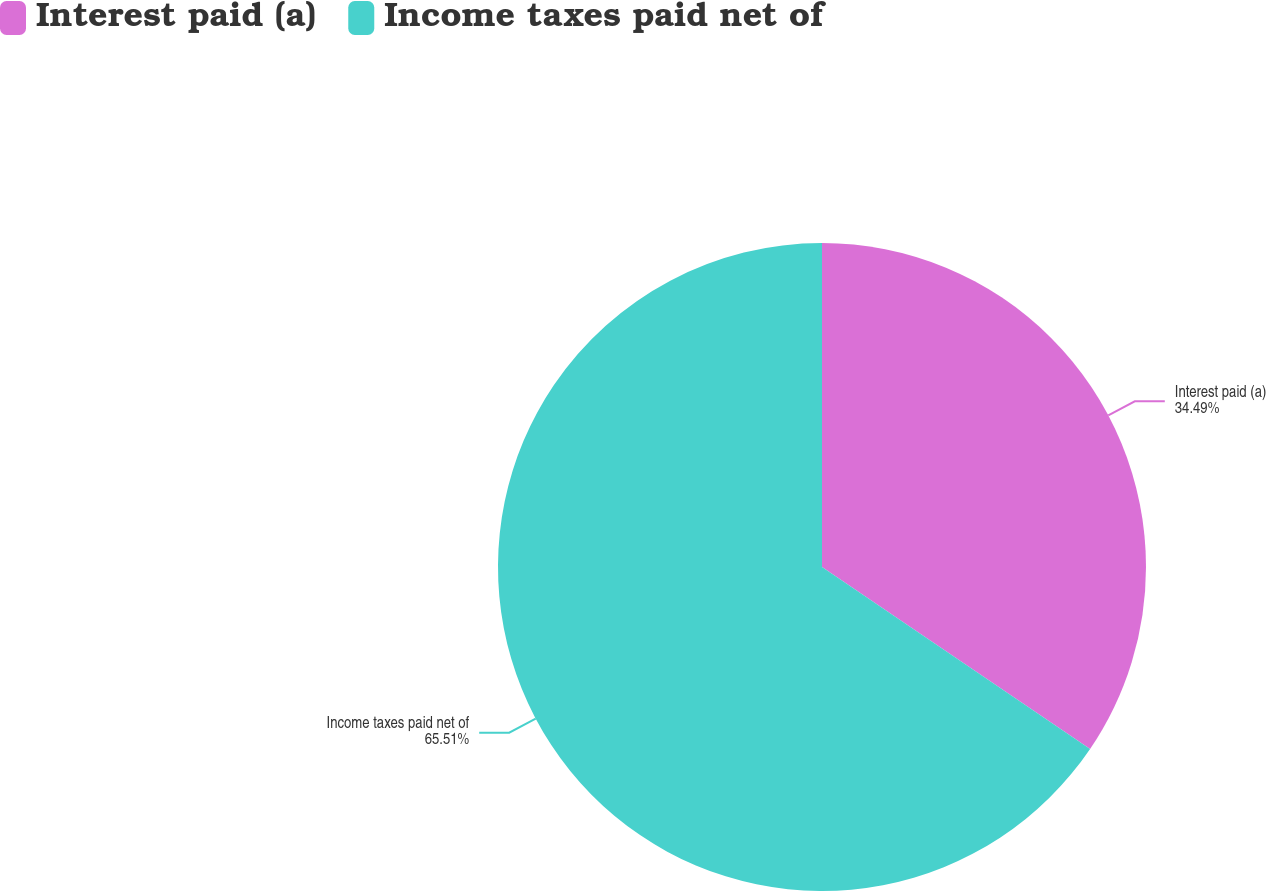Convert chart to OTSL. <chart><loc_0><loc_0><loc_500><loc_500><pie_chart><fcel>Interest paid (a)<fcel>Income taxes paid net of<nl><fcel>34.49%<fcel>65.51%<nl></chart> 